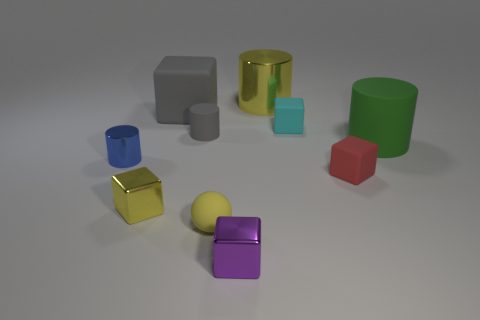What material is the large cylinder behind the small cube behind the blue cylinder? metal 